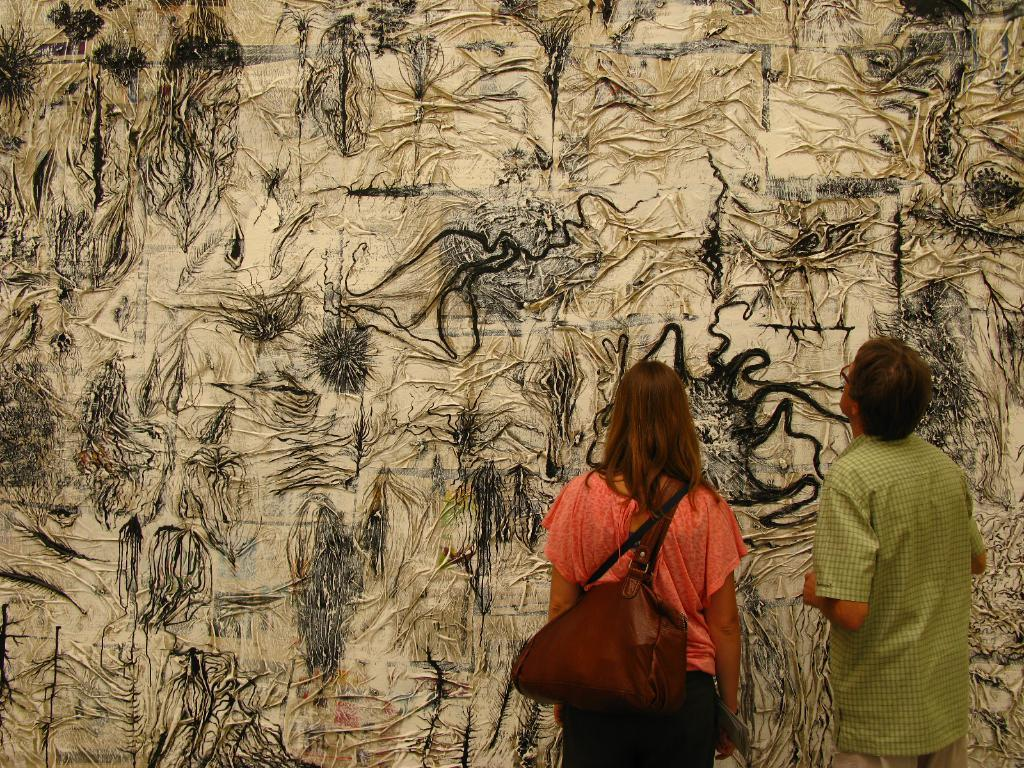Who are the people in the image? There is a man and a woman in the image. What is the woman holding or carrying? The woman is carrying a bag. What can be seen on the wall in the image? There is a painting on the wall. What is the writer doing in the image? There is no writer present in the image. Is the queen in the image? There is no queen present in the image. 